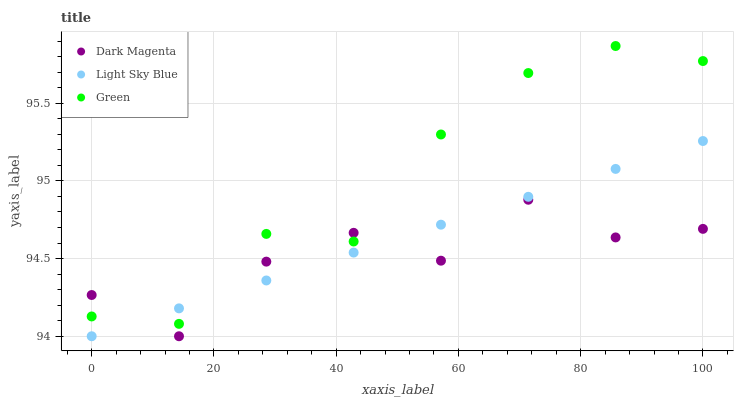Does Dark Magenta have the minimum area under the curve?
Answer yes or no. Yes. Does Green have the maximum area under the curve?
Answer yes or no. Yes. Does Green have the minimum area under the curve?
Answer yes or no. No. Does Dark Magenta have the maximum area under the curve?
Answer yes or no. No. Is Light Sky Blue the smoothest?
Answer yes or no. Yes. Is Dark Magenta the roughest?
Answer yes or no. Yes. Is Green the smoothest?
Answer yes or no. No. Is Green the roughest?
Answer yes or no. No. Does Light Sky Blue have the lowest value?
Answer yes or no. Yes. Does Green have the lowest value?
Answer yes or no. No. Does Green have the highest value?
Answer yes or no. Yes. Does Dark Magenta have the highest value?
Answer yes or no. No. Does Light Sky Blue intersect Dark Magenta?
Answer yes or no. Yes. Is Light Sky Blue less than Dark Magenta?
Answer yes or no. No. Is Light Sky Blue greater than Dark Magenta?
Answer yes or no. No. 